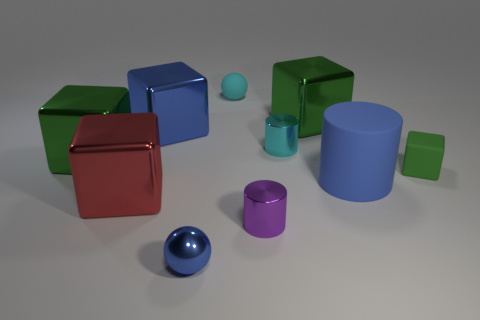Subtract all yellow spheres. How many green cubes are left? 3 Subtract all rubber blocks. How many blocks are left? 4 Subtract 2 cubes. How many cubes are left? 3 Subtract all red blocks. How many blocks are left? 4 Subtract all cyan cubes. Subtract all yellow cylinders. How many cubes are left? 5 Subtract all cylinders. How many objects are left? 7 Add 4 large matte objects. How many large matte objects exist? 5 Subtract 1 cyan cylinders. How many objects are left? 9 Subtract all big rubber objects. Subtract all green matte cubes. How many objects are left? 8 Add 2 big matte cylinders. How many big matte cylinders are left? 3 